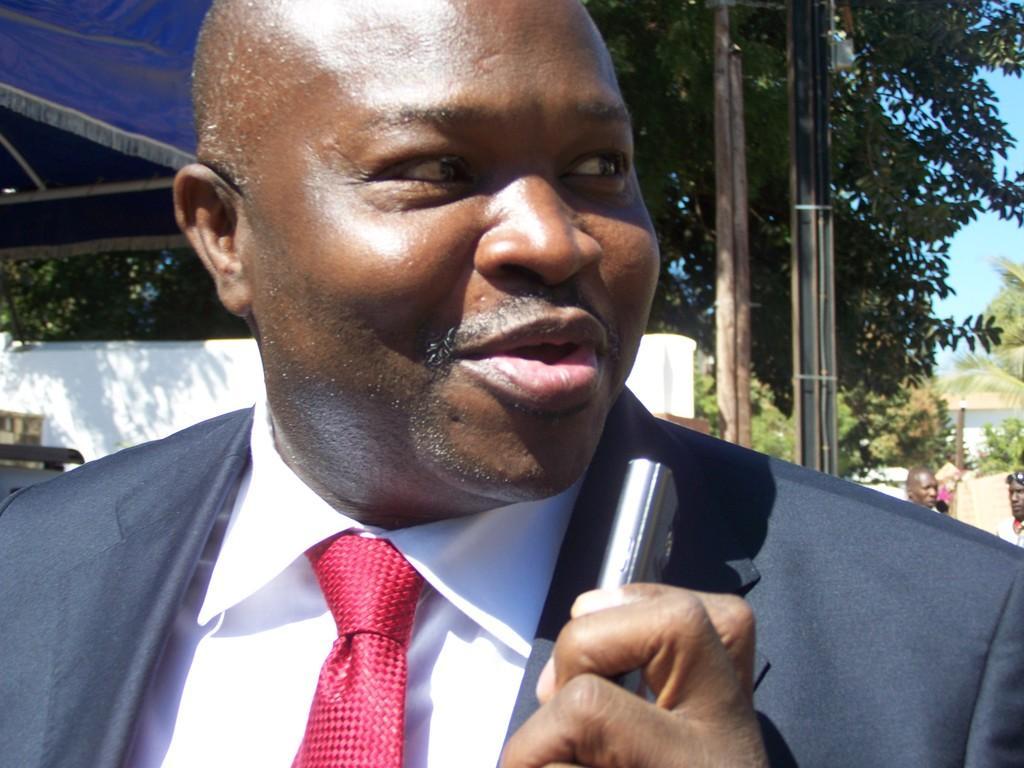Please provide a concise description of this image. In this image, we can see a man standing, he is holding an object, he is wearing a coat and a tie, in the background, we can see some trees and there is a white wall, on the right side top we can see the sky. 